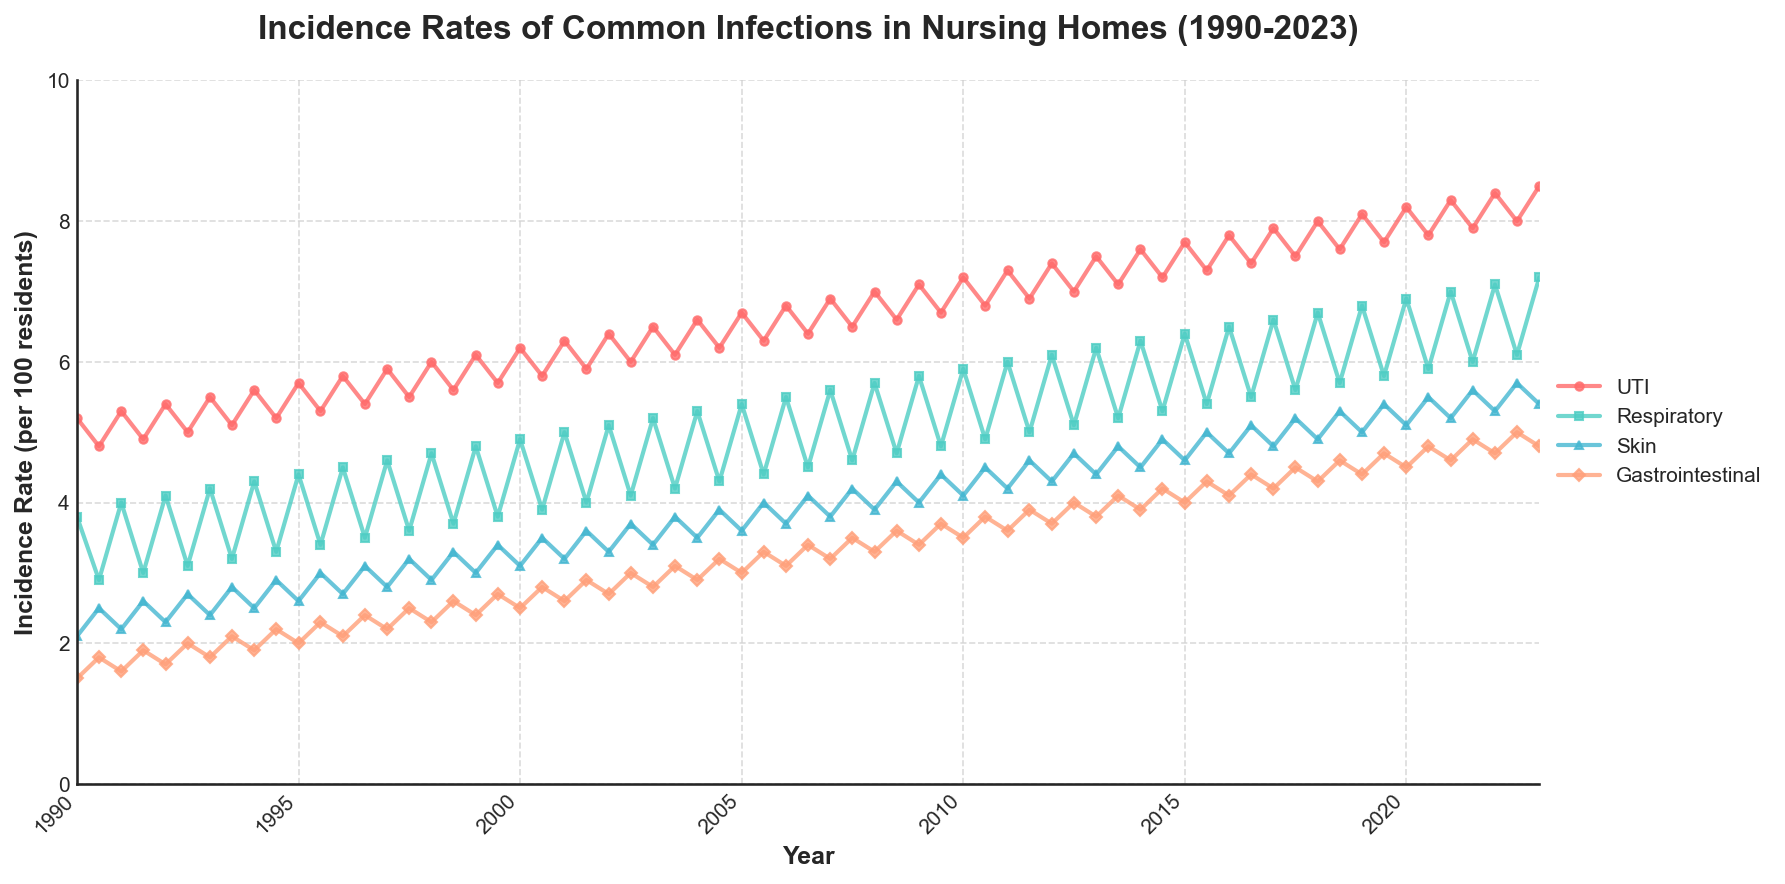How do the incidence rates of Respiratory infections compare between January 2000 and July 2000? In January 2000, the incidence rate for Respiratory infections is 4.9 per 100 residents. In July 2000, it is 3.9 per 100 residents. By comparing these values, we see that the rate in January is higher than in July by 1.0.
Answer: January is higher by 1.0 Which infection type shows the highest overall incidence rate in the given data? Looking at the chart, the UTI (Urinary Tract Infection) line consistently has the highest values throughout the period from 1990 to 2023 compared to Respiratory, Skin, and Gastrointestinal infections.
Answer: UTI In which year was the incidence rate of Skin infections the highest, and what was the value? The incidence rate of Skin infections peaks in January 2023 at a value of 5.4 per 100 residents. This can be observed by tracing the Skin infection line to its highest point on the chart and noting the corresponding year.
Answer: 2023, 5.4 What is the difference in the incidence rates of Gastrointestinal infections between January 1990 and January 2023? The incidence rate of Gastrointestinal infections was 1.5 per 100 residents in January 1990 and 4.8 per 100 residents in January 2023. Subtracting the former from the latter gives 4.8 - 1.5 = 3.3.
Answer: 3.3 Do any infection types show a clear seasonal pattern and if so, which months typically see higher rates? From the chart, every infection type shows a clear seasonal pattern with higher incidence rates in January compared to July. This pattern is consistent across all infection types.
Answer: January What trend can be observed in the incidence rate of UTI infections from 1990 to 2023? The incidence rate of UTI infections shows a steady increase from 5.2 per 100 residents in January 1990 to 8.5 per 100 residents in January 2023. This indicates a general upwards trend over time.
Answer: Steady increase Calculate the average incidence rate for Gastrointestinal infections over the entire period. To calculate the average, we sum up all values of Gastrointestinal infections from the data and divide by the number of values. The sum is 3.4 + 4.8 = 8.2 (1990), 3.7 + 3.4 +... = X, total months = 68, average rate = X / 68. This requires specific data calculation beyond visual interpretation.
Answer: Needs calculation Which infection type and year combination shows the largest decrease from January to July? Analyzing the chart, the largest decrease appears in Respiratory infections in the year 2001, where it drops from 5.0 in January to 4.0 in July, a decrease of 1.0.
Answer: Respiratory, 2001 